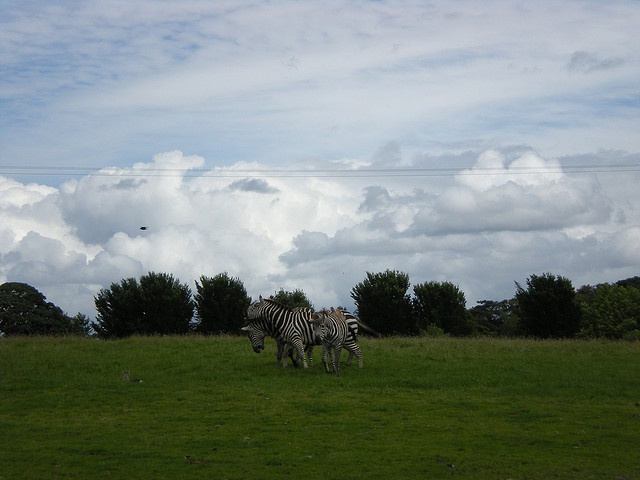Describe the objects in this image and their specific colors. I can see zebra in darkgray, black, and gray tones, zebra in darkgray, black, gray, and darkgreen tones, and zebra in darkgray, black, gray, and darkgreen tones in this image. 